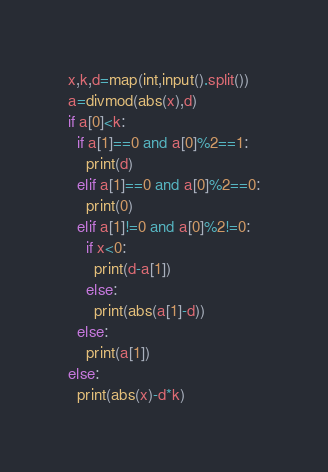<code> <loc_0><loc_0><loc_500><loc_500><_Python_>x,k,d=map(int,input().split())
a=divmod(abs(x),d)  
if a[0]<k:
  if a[1]==0 and a[0]%2==1:
    print(d)
  elif a[1]==0 and a[0]%2==0:
    print(0)
  elif a[1]!=0 and a[0]%2!=0:
    if x<0:
      print(d-a[1])
    else:
      print(abs(a[1]-d))
  else:
    print(a[1])
else:
  print(abs(x)-d*k)
</code> 